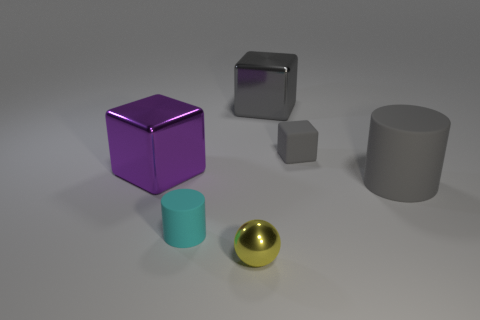How many cyan things are left of the cube that is left of the yellow shiny thing?
Your answer should be compact. 0. What number of things are either gray metal blocks or cyan matte objects?
Your answer should be compact. 2. Is the shape of the big purple thing the same as the cyan rubber thing?
Provide a short and direct response. No. What is the small block made of?
Ensure brevity in your answer.  Rubber. What number of objects are behind the small cyan object and left of the yellow ball?
Keep it short and to the point. 1. Do the cyan rubber object and the rubber cube have the same size?
Offer a terse response. Yes. Is the size of the metallic object behind the purple metal thing the same as the purple metallic block?
Give a very brief answer. Yes. There is a big metallic thing that is right of the purple metal block; what is its color?
Your answer should be very brief. Gray. What number of big cylinders are there?
Make the answer very short. 1. What is the shape of the big gray thing that is the same material as the small cylinder?
Make the answer very short. Cylinder. 